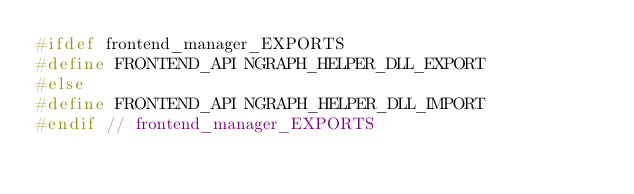Convert code to text. <code><loc_0><loc_0><loc_500><loc_500><_C++_>#ifdef frontend_manager_EXPORTS
#define FRONTEND_API NGRAPH_HELPER_DLL_EXPORT
#else
#define FRONTEND_API NGRAPH_HELPER_DLL_IMPORT
#endif // frontend_manager_EXPORTS
</code> 